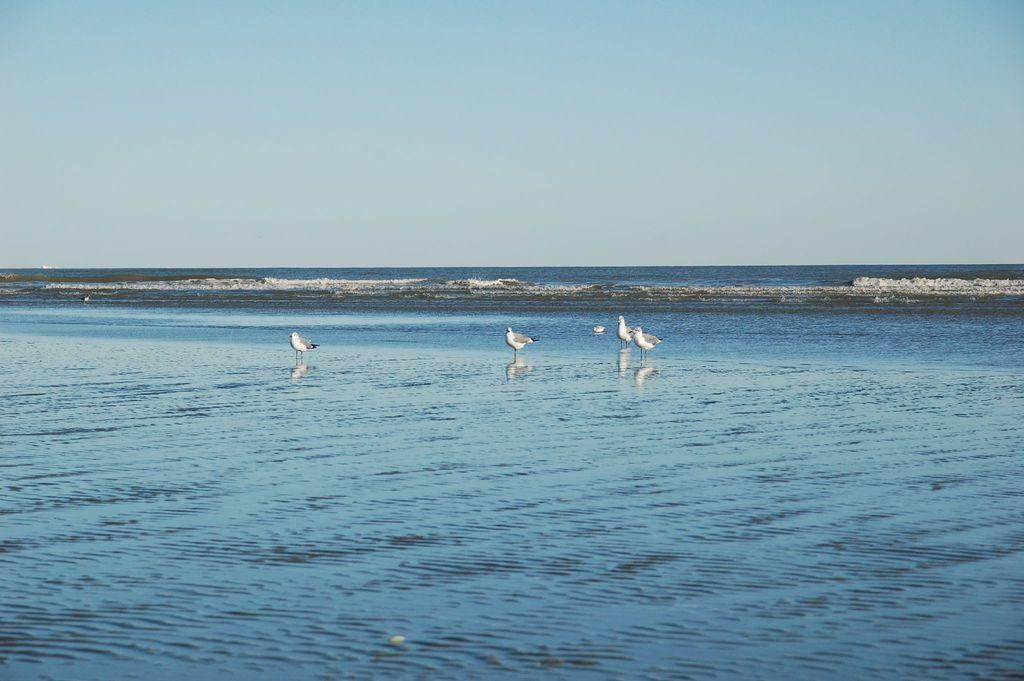What animals can be seen in the water in the image? There are birds standing in the water in the image. What type of water body might the birds be standing in? The water may be part of a sea. What natural phenomenon might be present in the water? Waves may be present in the water. What else can be seen in the image besides the birds and water? The sky is visible in the image. What type of lace can be seen on the birds' wings in the image? There is no lace present on the birds' wings in the image; they are simply feathers. 